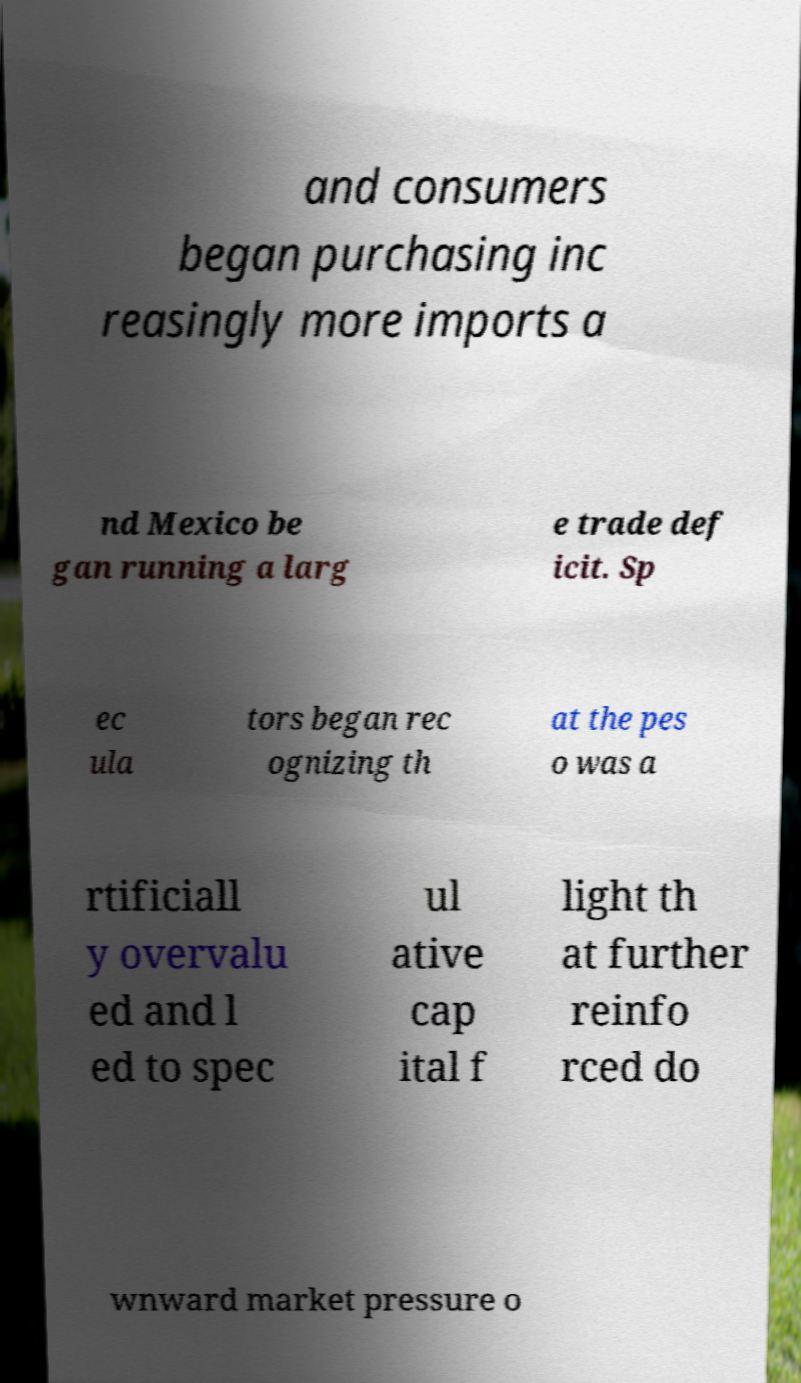Could you extract and type out the text from this image? and consumers began purchasing inc reasingly more imports a nd Mexico be gan running a larg e trade def icit. Sp ec ula tors began rec ognizing th at the pes o was a rtificiall y overvalu ed and l ed to spec ul ative cap ital f light th at further reinfo rced do wnward market pressure o 